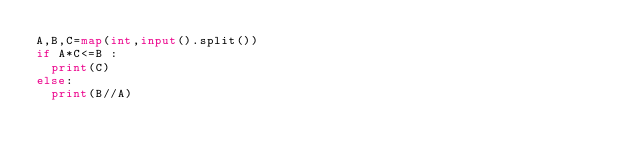<code> <loc_0><loc_0><loc_500><loc_500><_Python_>A,B,C=map(int,input().split())
if A*C<=B :
  print(C)
else:
  print(B//A)</code> 